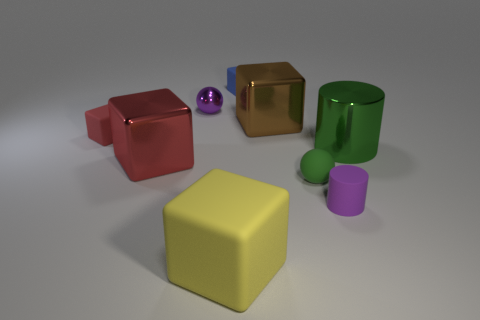What number of spheres have the same material as the green cylinder? 1 